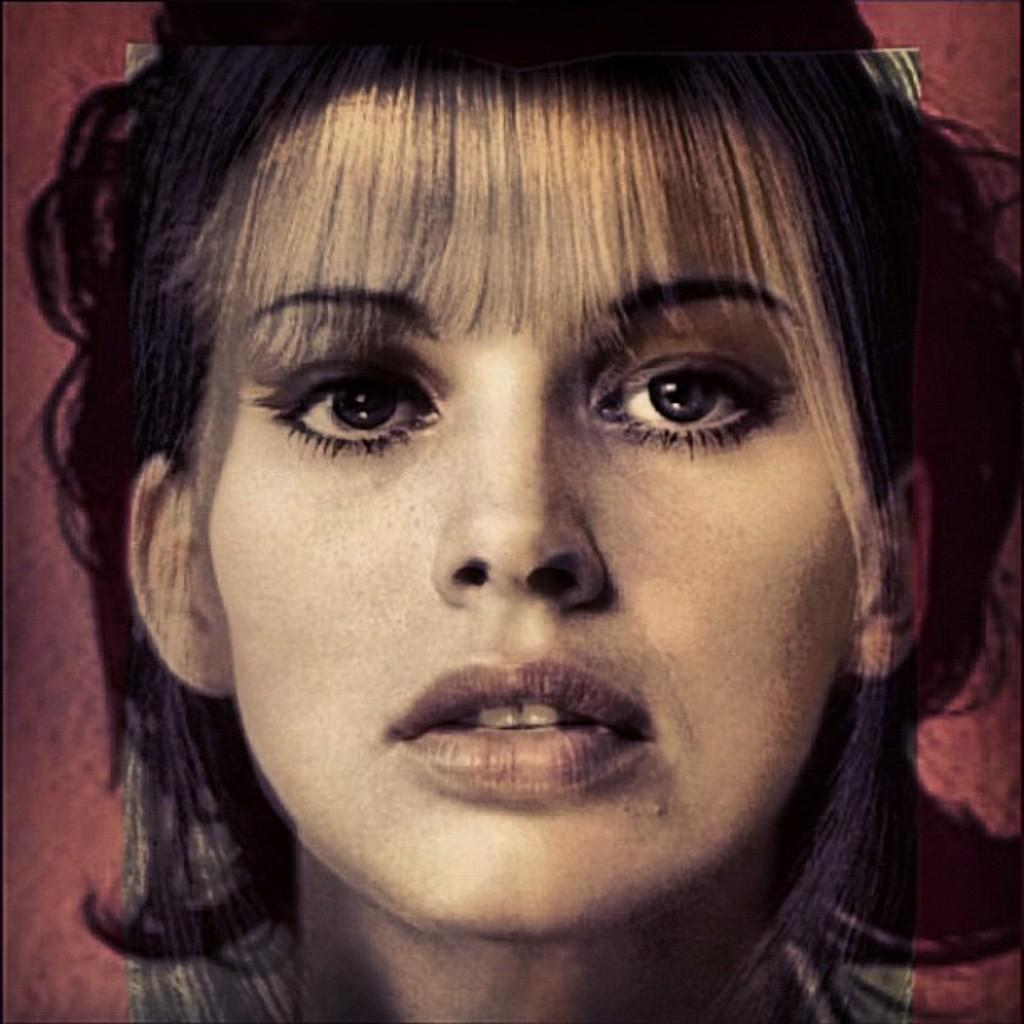What is the main subject of the image? There is a depiction of a woman's face in the image. What type of grain is being used to whip the woman's face in the image? There is no grain or whipping action present in the image; it features a depiction of a woman's face. 